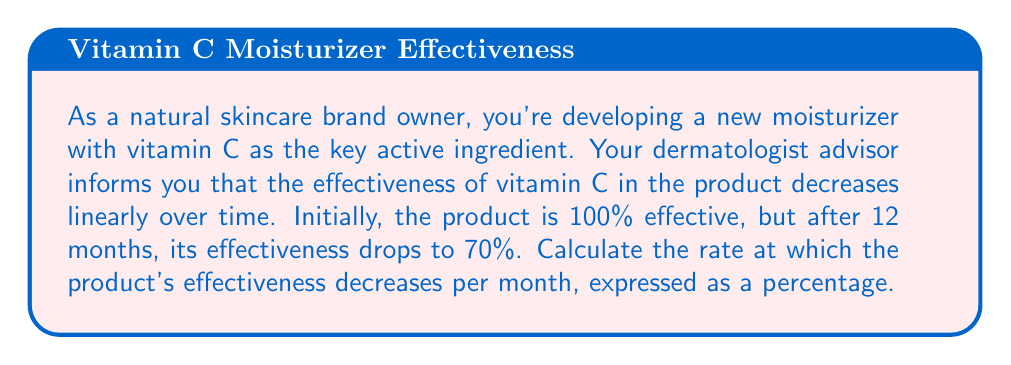Give your solution to this math problem. To solve this problem, we need to use the concept of linear rate of change. Let's break it down step-by-step:

1. Define our variables:
   $t$ = time in months
   $E(t)$ = effectiveness as a function of time

2. We know two points on this linear function:
   At $t = 0$, $E(0) = 100\%$
   At $t = 12$, $E(12) = 70\%$

3. The rate of change (slope) can be calculated using the formula:

   $$\text{Rate of change} = \frac{\text{Change in effectiveness}}{\text{Change in time}} = \frac{\Delta E}{\Delta t}$$

4. Plugging in our known values:

   $$\text{Rate of change} = \frac{E(12) - E(0)}{12 - 0} = \frac{70\% - 100\%}{12}$$

5. Simplify:

   $$\text{Rate of change} = \frac{-30\%}{12} = -2.5\% \text{ per month}$$

6. The question asks for the rate at which effectiveness decreases, so we take the absolute value:

   $$\text{Rate of decrease} = |{-2.5\%}| = 2.5\% \text{ per month}$$

Therefore, the product's effectiveness decreases at a rate of 2.5% per month.
Answer: The rate at which the product's effectiveness decreases is $2.5\%$ per month. 